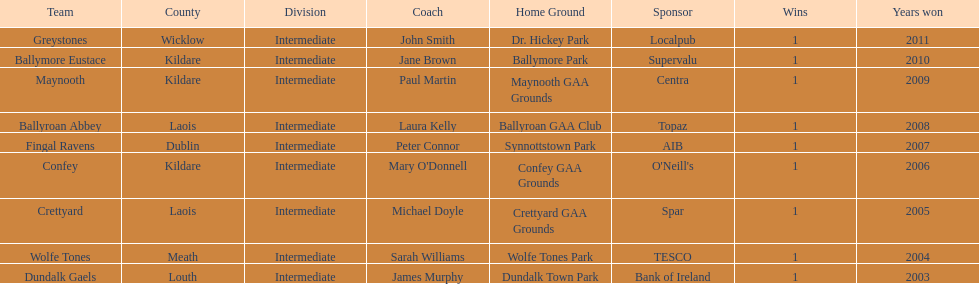Parse the full table. {'header': ['Team', 'County', 'Division', 'Coach', 'Home Ground', 'Sponsor', 'Wins', 'Years won'], 'rows': [['Greystones', 'Wicklow', 'Intermediate', 'John Smith', 'Dr. Hickey Park', 'Localpub', '1', '2011'], ['Ballymore Eustace', 'Kildare', 'Intermediate', 'Jane Brown', 'Ballymore Park', 'Supervalu', '1', '2010'], ['Maynooth', 'Kildare', 'Intermediate', 'Paul Martin', 'Maynooth GAA Grounds', 'Centra', '1', '2009'], ['Ballyroan Abbey', 'Laois', 'Intermediate', 'Laura Kelly', 'Ballyroan GAA Club', 'Topaz', '1', '2008'], ['Fingal Ravens', 'Dublin', 'Intermediate', 'Peter Connor', 'Synnottstown Park', 'AIB', '1', '2007'], ['Confey', 'Kildare', 'Intermediate', "Mary O'Donnell", 'Confey GAA Grounds', "O'Neill's", '1', '2006'], ['Crettyard', 'Laois', 'Intermediate', 'Michael Doyle', 'Crettyard GAA Grounds', 'Spar', '1', '2005'], ['Wolfe Tones', 'Meath', 'Intermediate', 'Sarah Williams', 'Wolfe Tones Park', 'TESCO', '1', '2004'], ['Dundalk Gaels', 'Louth', 'Intermediate', 'James Murphy', 'Dundalk Town Park', 'Bank of Ireland', '1', '2003']]} Which team won after ballymore eustace? Greystones. 